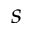<formula> <loc_0><loc_0><loc_500><loc_500>s</formula> 